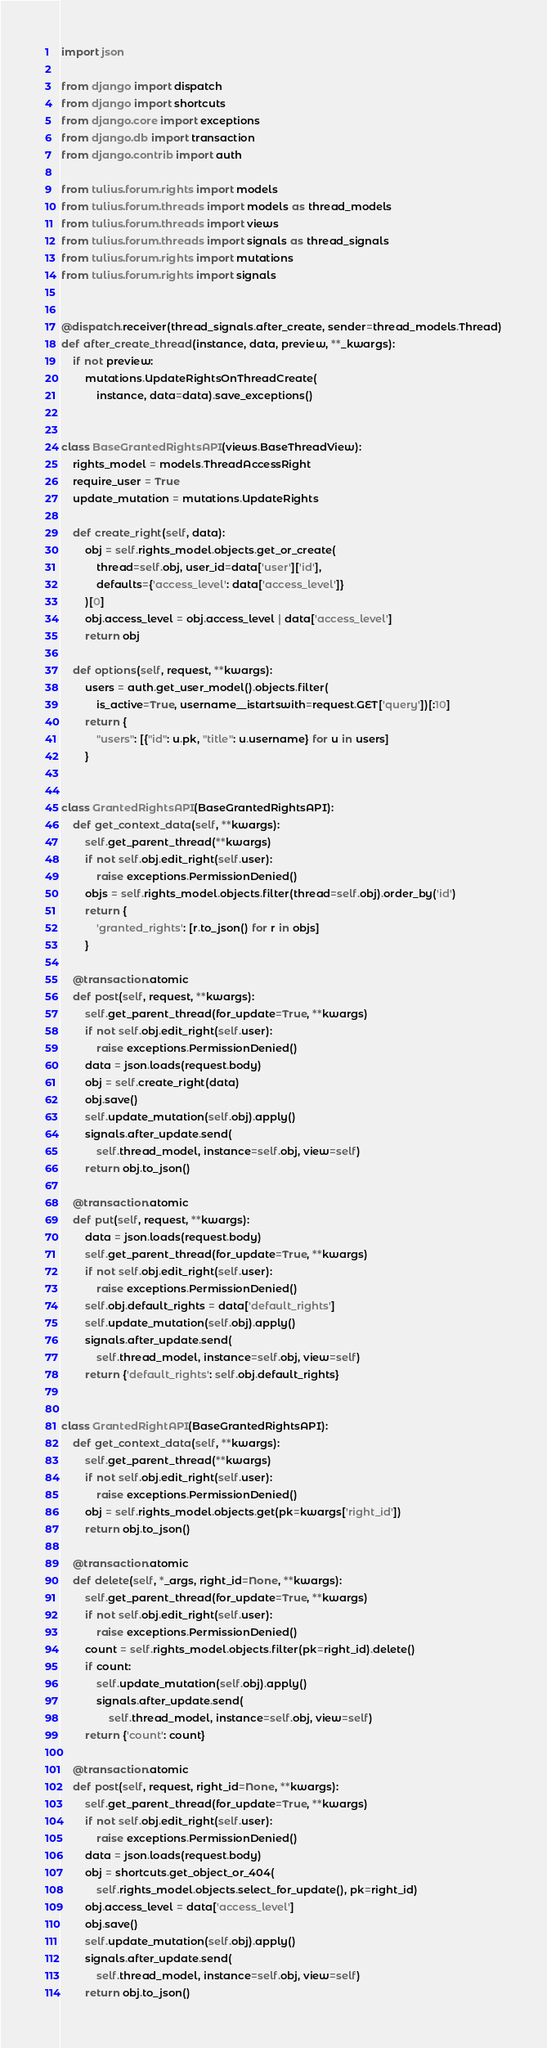<code> <loc_0><loc_0><loc_500><loc_500><_Python_>import json

from django import dispatch
from django import shortcuts
from django.core import exceptions
from django.db import transaction
from django.contrib import auth

from tulius.forum.rights import models
from tulius.forum.threads import models as thread_models
from tulius.forum.threads import views
from tulius.forum.threads import signals as thread_signals
from tulius.forum.rights import mutations
from tulius.forum.rights import signals


@dispatch.receiver(thread_signals.after_create, sender=thread_models.Thread)
def after_create_thread(instance, data, preview, **_kwargs):
    if not preview:
        mutations.UpdateRightsOnThreadCreate(
            instance, data=data).save_exceptions()


class BaseGrantedRightsAPI(views.BaseThreadView):
    rights_model = models.ThreadAccessRight
    require_user = True
    update_mutation = mutations.UpdateRights

    def create_right(self, data):
        obj = self.rights_model.objects.get_or_create(
            thread=self.obj, user_id=data['user']['id'],
            defaults={'access_level': data['access_level']}
        )[0]
        obj.access_level = obj.access_level | data['access_level']
        return obj

    def options(self, request, **kwargs):
        users = auth.get_user_model().objects.filter(
            is_active=True, username__istartswith=request.GET['query'])[:10]
        return {
            "users": [{"id": u.pk, "title": u.username} for u in users]
        }


class GrantedRightsAPI(BaseGrantedRightsAPI):
    def get_context_data(self, **kwargs):
        self.get_parent_thread(**kwargs)
        if not self.obj.edit_right(self.user):
            raise exceptions.PermissionDenied()
        objs = self.rights_model.objects.filter(thread=self.obj).order_by('id')
        return {
            'granted_rights': [r.to_json() for r in objs]
        }

    @transaction.atomic
    def post(self, request, **kwargs):
        self.get_parent_thread(for_update=True, **kwargs)
        if not self.obj.edit_right(self.user):
            raise exceptions.PermissionDenied()
        data = json.loads(request.body)
        obj = self.create_right(data)
        obj.save()
        self.update_mutation(self.obj).apply()
        signals.after_update.send(
            self.thread_model, instance=self.obj, view=self)
        return obj.to_json()

    @transaction.atomic
    def put(self, request, **kwargs):
        data = json.loads(request.body)
        self.get_parent_thread(for_update=True, **kwargs)
        if not self.obj.edit_right(self.user):
            raise exceptions.PermissionDenied()
        self.obj.default_rights = data['default_rights']
        self.update_mutation(self.obj).apply()
        signals.after_update.send(
            self.thread_model, instance=self.obj, view=self)
        return {'default_rights': self.obj.default_rights}


class GrantedRightAPI(BaseGrantedRightsAPI):
    def get_context_data(self, **kwargs):
        self.get_parent_thread(**kwargs)
        if not self.obj.edit_right(self.user):
            raise exceptions.PermissionDenied()
        obj = self.rights_model.objects.get(pk=kwargs['right_id'])
        return obj.to_json()

    @transaction.atomic
    def delete(self, *_args, right_id=None, **kwargs):
        self.get_parent_thread(for_update=True, **kwargs)
        if not self.obj.edit_right(self.user):
            raise exceptions.PermissionDenied()
        count = self.rights_model.objects.filter(pk=right_id).delete()
        if count:
            self.update_mutation(self.obj).apply()
            signals.after_update.send(
                self.thread_model, instance=self.obj, view=self)
        return {'count': count}

    @transaction.atomic
    def post(self, request, right_id=None, **kwargs):
        self.get_parent_thread(for_update=True, **kwargs)
        if not self.obj.edit_right(self.user):
            raise exceptions.PermissionDenied()
        data = json.loads(request.body)
        obj = shortcuts.get_object_or_404(
            self.rights_model.objects.select_for_update(), pk=right_id)
        obj.access_level = data['access_level']
        obj.save()
        self.update_mutation(self.obj).apply()
        signals.after_update.send(
            self.thread_model, instance=self.obj, view=self)
        return obj.to_json()
</code> 